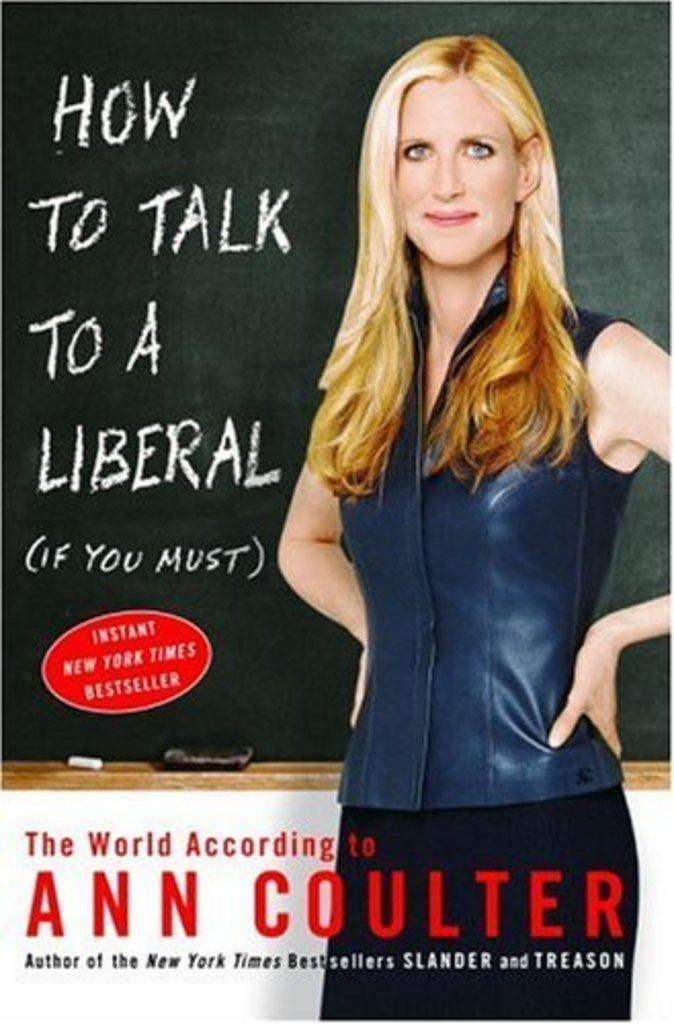What is the main subject in the center of the image? There is a poster in the center of the image. What is shown on the poster? The poster contains an image of one person and a board. Are there any words on the poster? Yes, the poster contains some text. What else can be seen on the poster besides the person and text? The poster also has some objects depicted on it. Is there a cat attending the party depicted on the poster? There is no party depicted on the poster, and therefore no cat attending it. What type of treatment is being offered to the person on the poster? The poster does not depict any treatment being offered to the person; it simply shows an image of one person and a board. 